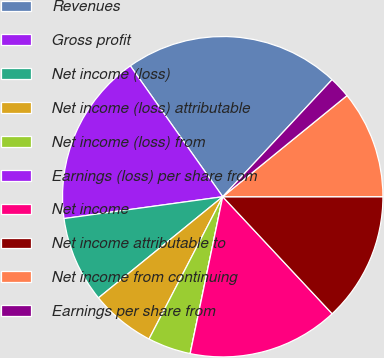Convert chart to OTSL. <chart><loc_0><loc_0><loc_500><loc_500><pie_chart><fcel>Revenues<fcel>Gross profit<fcel>Net income (loss)<fcel>Net income (loss) attributable<fcel>Net income (loss) from<fcel>Earnings (loss) per share from<fcel>Net income<fcel>Net income attributable to<fcel>Net income from continuing<fcel>Earnings per share from<nl><fcel>21.74%<fcel>17.39%<fcel>8.7%<fcel>6.52%<fcel>4.35%<fcel>0.0%<fcel>15.22%<fcel>13.04%<fcel>10.87%<fcel>2.17%<nl></chart> 